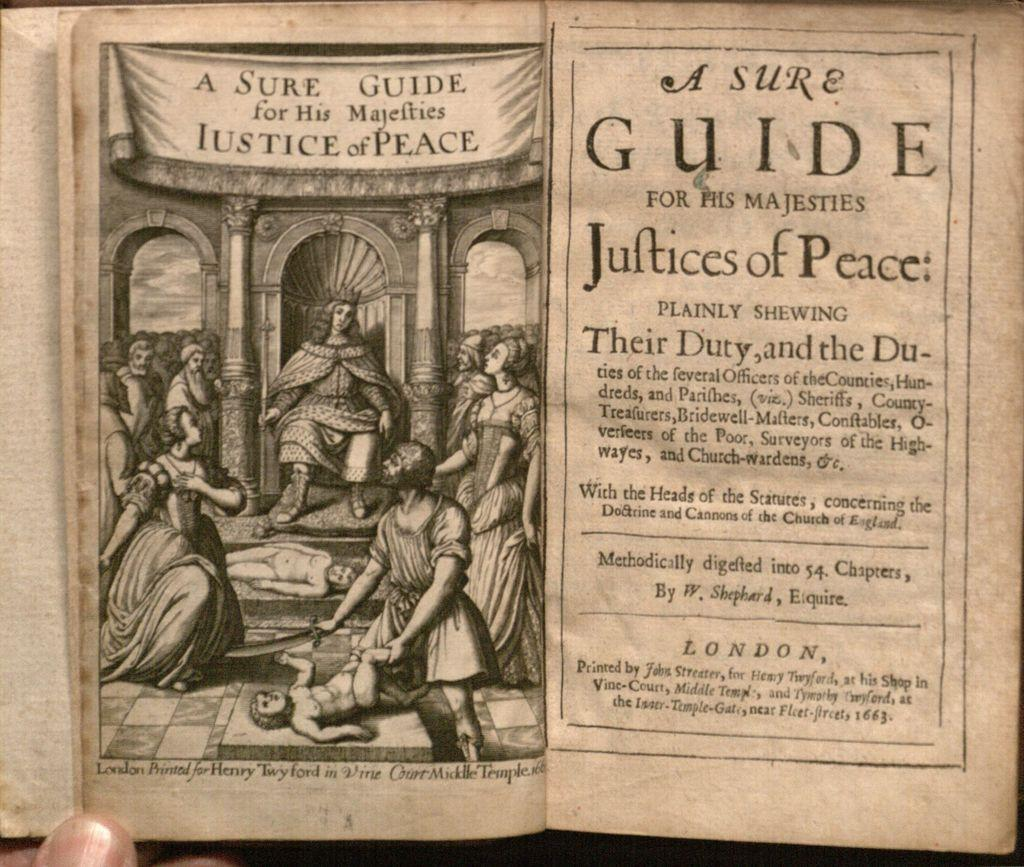<image>
Provide a brief description of the given image. First page of a book titled A sure Guide for his majesties justice of peace 